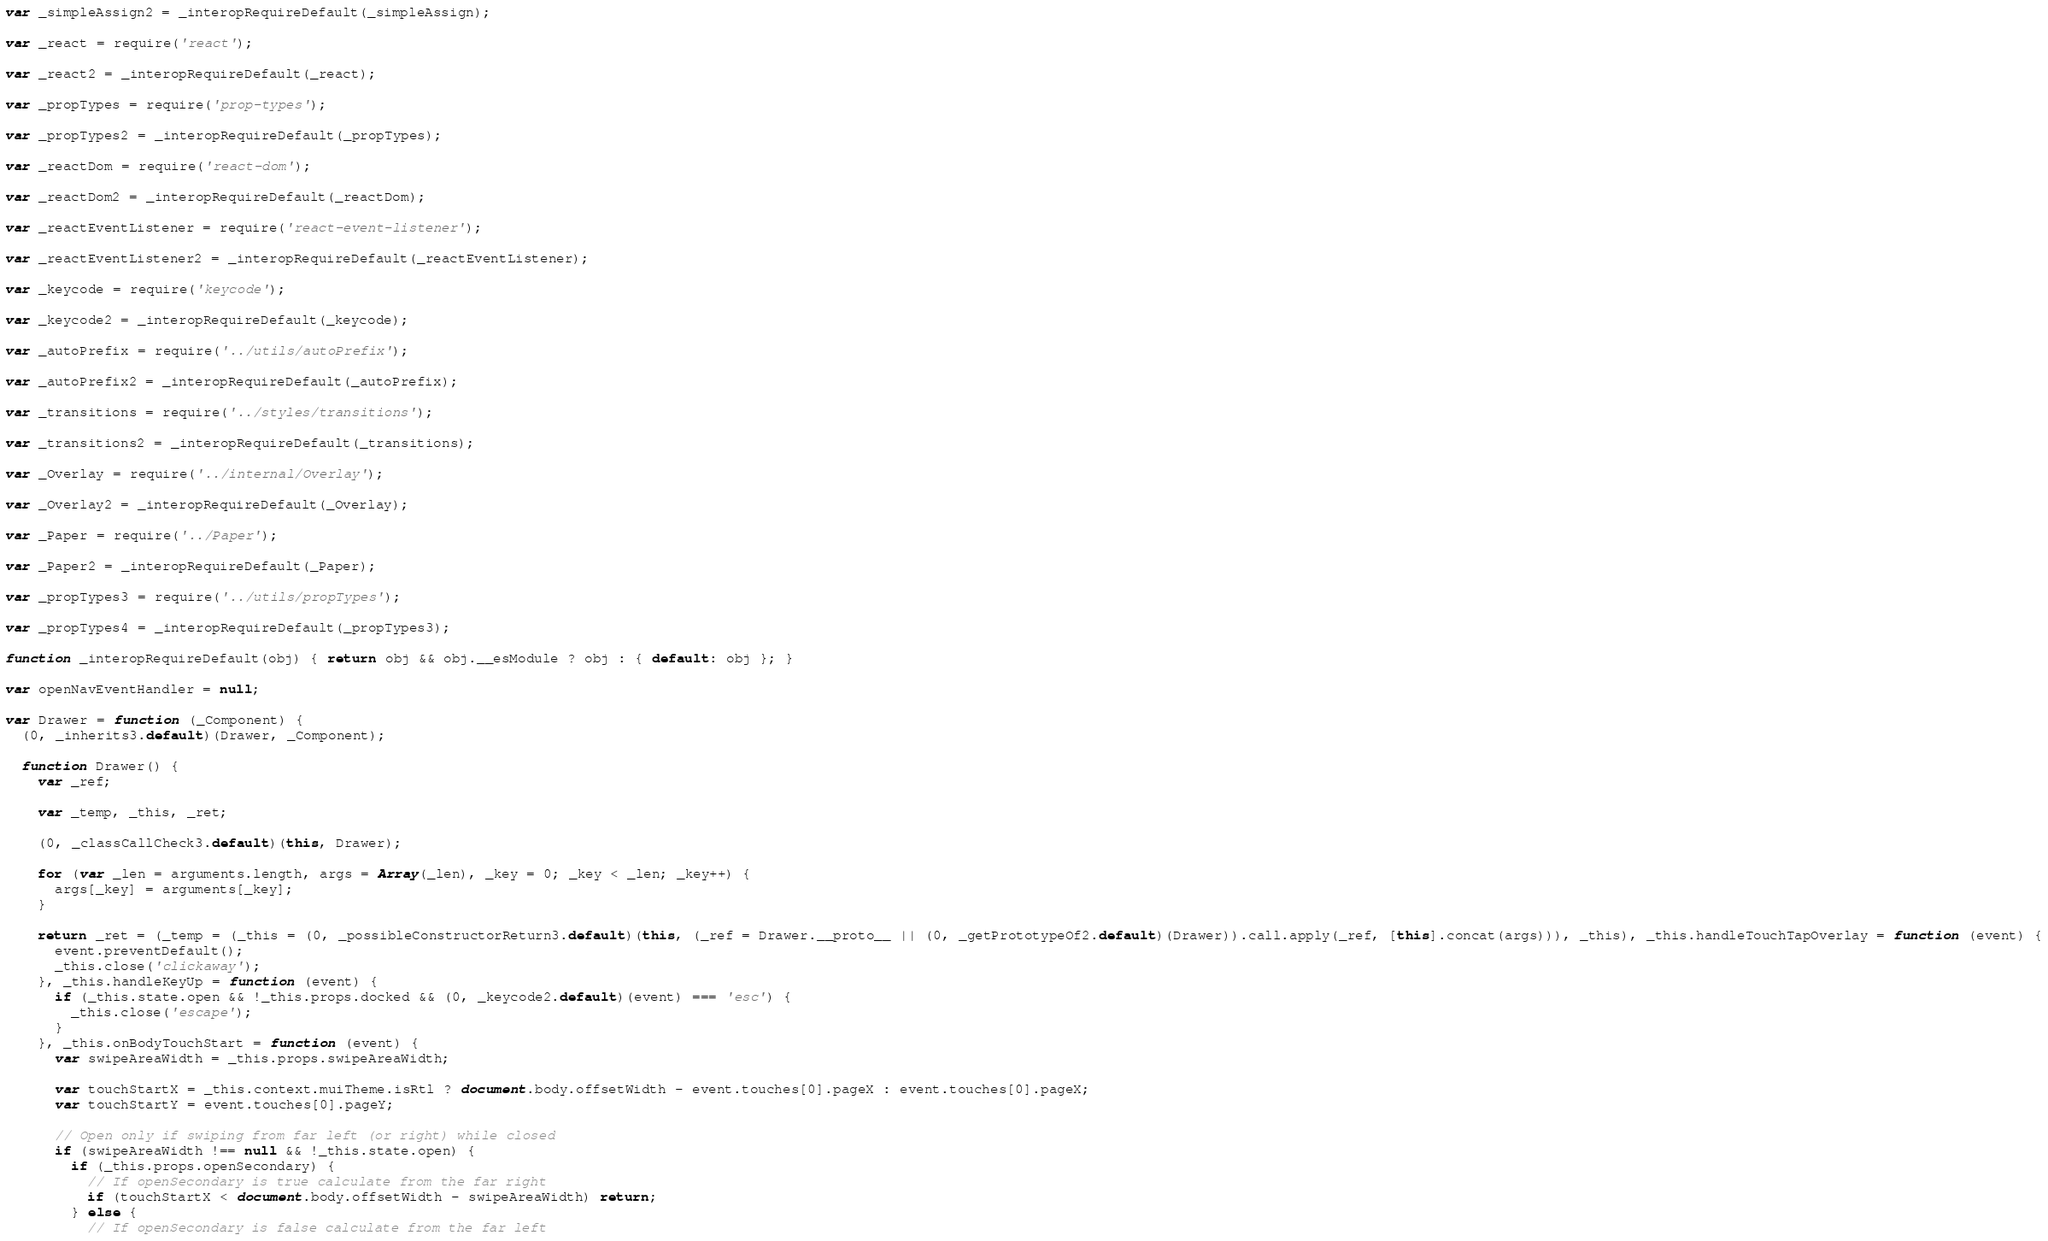Convert code to text. <code><loc_0><loc_0><loc_500><loc_500><_JavaScript_>
var _simpleAssign2 = _interopRequireDefault(_simpleAssign);

var _react = require('react');

var _react2 = _interopRequireDefault(_react);

var _propTypes = require('prop-types');

var _propTypes2 = _interopRequireDefault(_propTypes);

var _reactDom = require('react-dom');

var _reactDom2 = _interopRequireDefault(_reactDom);

var _reactEventListener = require('react-event-listener');

var _reactEventListener2 = _interopRequireDefault(_reactEventListener);

var _keycode = require('keycode');

var _keycode2 = _interopRequireDefault(_keycode);

var _autoPrefix = require('../utils/autoPrefix');

var _autoPrefix2 = _interopRequireDefault(_autoPrefix);

var _transitions = require('../styles/transitions');

var _transitions2 = _interopRequireDefault(_transitions);

var _Overlay = require('../internal/Overlay');

var _Overlay2 = _interopRequireDefault(_Overlay);

var _Paper = require('../Paper');

var _Paper2 = _interopRequireDefault(_Paper);

var _propTypes3 = require('../utils/propTypes');

var _propTypes4 = _interopRequireDefault(_propTypes3);

function _interopRequireDefault(obj) { return obj && obj.__esModule ? obj : { default: obj }; }

var openNavEventHandler = null;

var Drawer = function (_Component) {
  (0, _inherits3.default)(Drawer, _Component);

  function Drawer() {
    var _ref;

    var _temp, _this, _ret;

    (0, _classCallCheck3.default)(this, Drawer);

    for (var _len = arguments.length, args = Array(_len), _key = 0; _key < _len; _key++) {
      args[_key] = arguments[_key];
    }

    return _ret = (_temp = (_this = (0, _possibleConstructorReturn3.default)(this, (_ref = Drawer.__proto__ || (0, _getPrototypeOf2.default)(Drawer)).call.apply(_ref, [this].concat(args))), _this), _this.handleTouchTapOverlay = function (event) {
      event.preventDefault();
      _this.close('clickaway');
    }, _this.handleKeyUp = function (event) {
      if (_this.state.open && !_this.props.docked && (0, _keycode2.default)(event) === 'esc') {
        _this.close('escape');
      }
    }, _this.onBodyTouchStart = function (event) {
      var swipeAreaWidth = _this.props.swipeAreaWidth;

      var touchStartX = _this.context.muiTheme.isRtl ? document.body.offsetWidth - event.touches[0].pageX : event.touches[0].pageX;
      var touchStartY = event.touches[0].pageY;

      // Open only if swiping from far left (or right) while closed
      if (swipeAreaWidth !== null && !_this.state.open) {
        if (_this.props.openSecondary) {
          // If openSecondary is true calculate from the far right
          if (touchStartX < document.body.offsetWidth - swipeAreaWidth) return;
        } else {
          // If openSecondary is false calculate from the far left</code> 